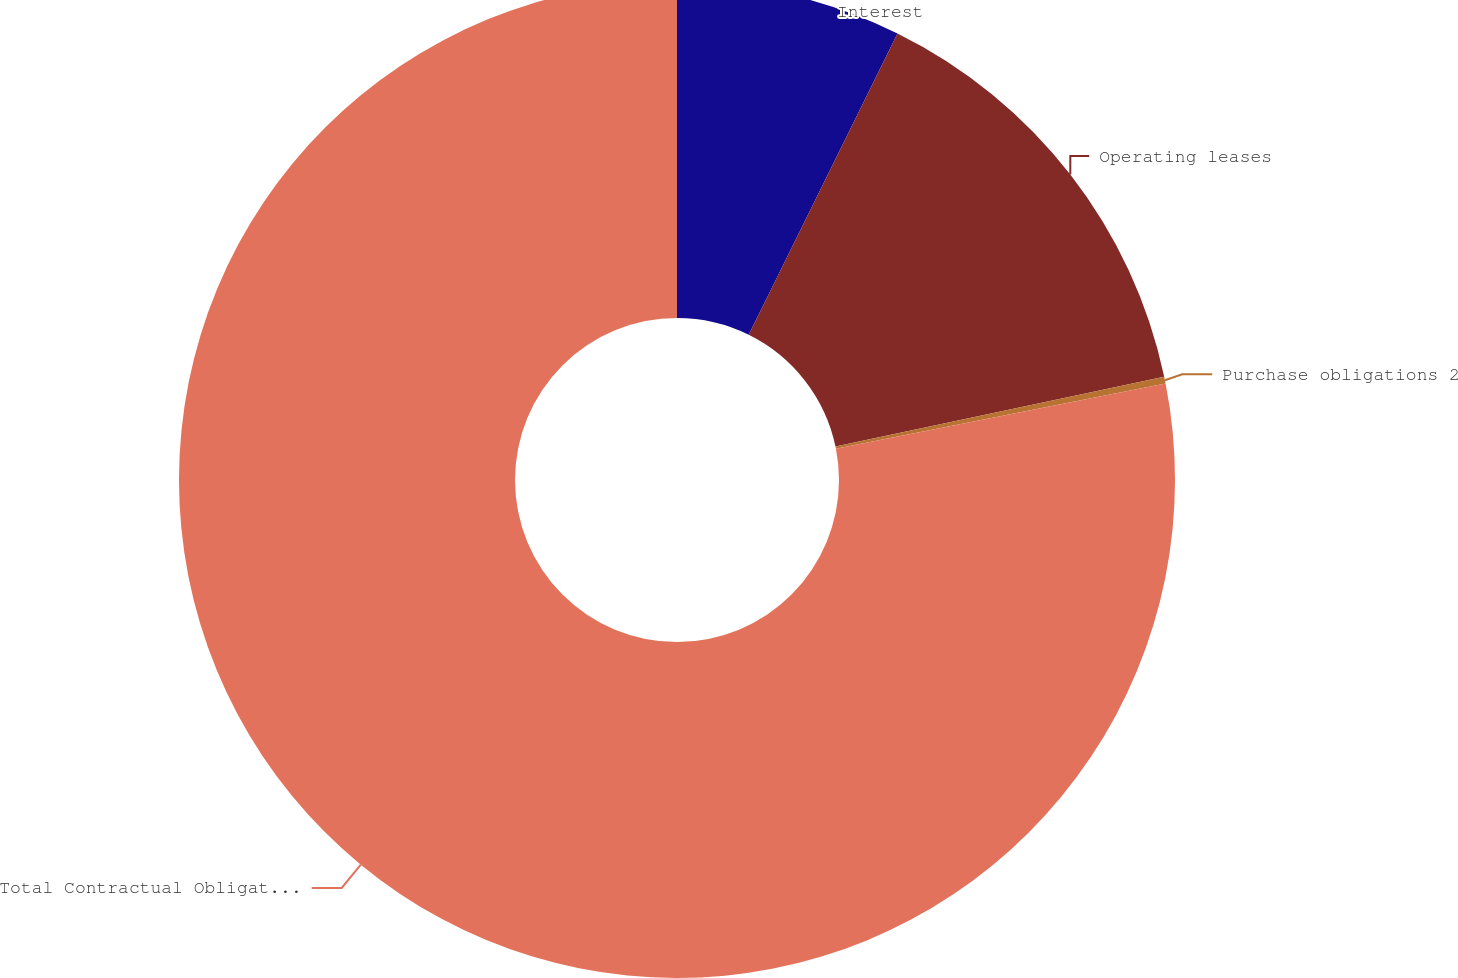Convert chart to OTSL. <chart><loc_0><loc_0><loc_500><loc_500><pie_chart><fcel>Interest<fcel>Operating leases<fcel>Purchase obligations 2<fcel>Total Contractual Obligations<nl><fcel>7.3%<fcel>14.38%<fcel>0.22%<fcel>78.1%<nl></chart> 